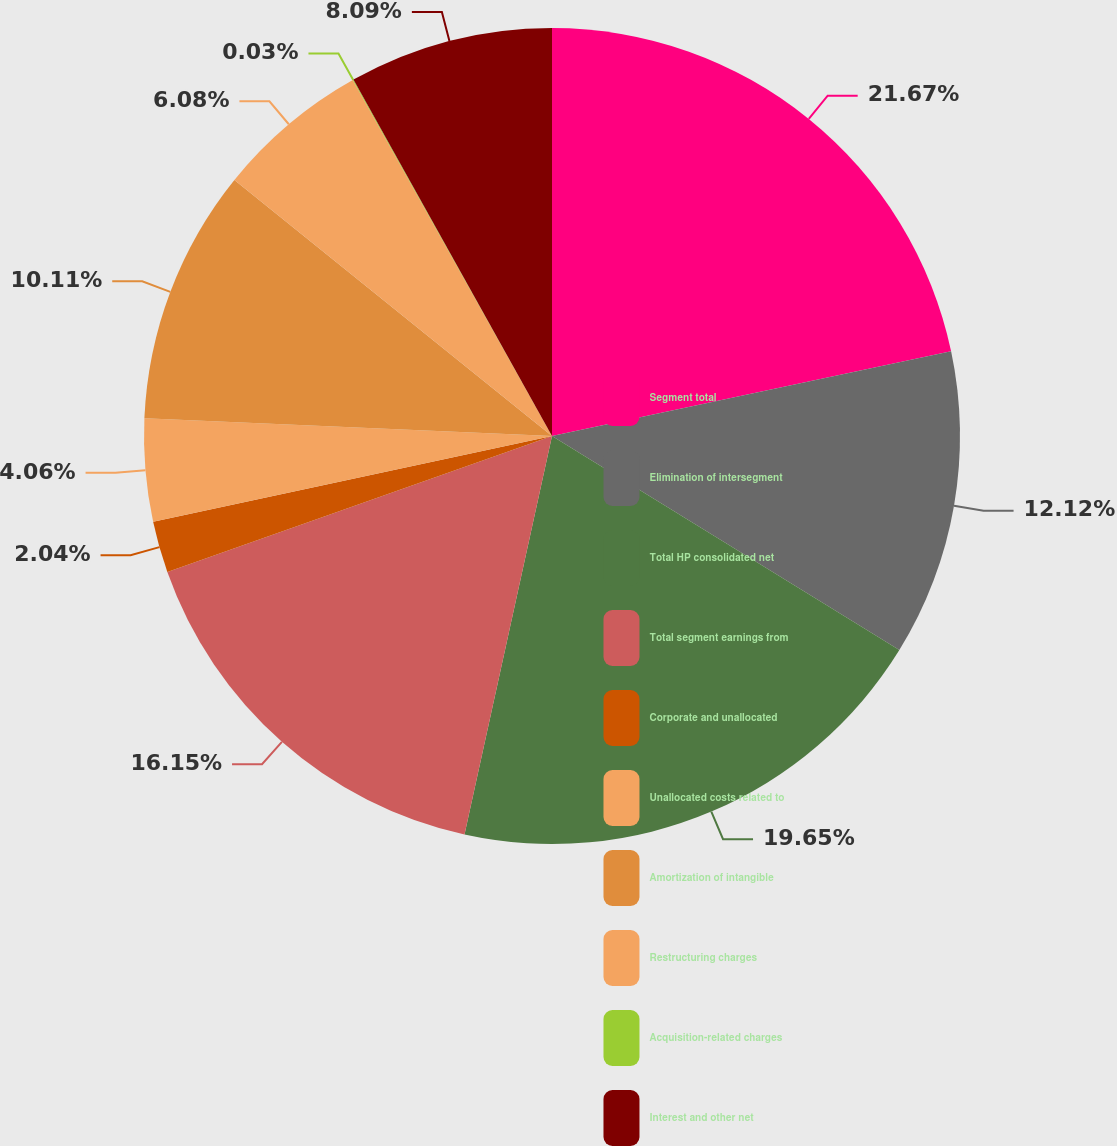Convert chart. <chart><loc_0><loc_0><loc_500><loc_500><pie_chart><fcel>Segment total<fcel>Elimination of intersegment<fcel>Total HP consolidated net<fcel>Total segment earnings from<fcel>Corporate and unallocated<fcel>Unallocated costs related to<fcel>Amortization of intangible<fcel>Restructuring charges<fcel>Acquisition-related charges<fcel>Interest and other net<nl><fcel>21.67%<fcel>12.12%<fcel>19.65%<fcel>16.15%<fcel>2.04%<fcel>4.06%<fcel>10.11%<fcel>6.08%<fcel>0.03%<fcel>8.09%<nl></chart> 